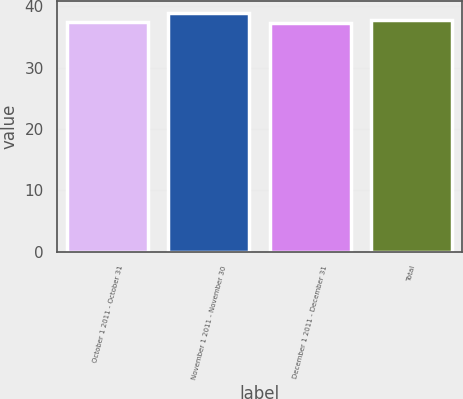<chart> <loc_0><loc_0><loc_500><loc_500><bar_chart><fcel>October 1 2011 - October 31<fcel>November 1 2011 - November 30<fcel>December 1 2011 - December 31<fcel>Total<nl><fcel>37.48<fcel>38.96<fcel>37.31<fcel>37.82<nl></chart> 